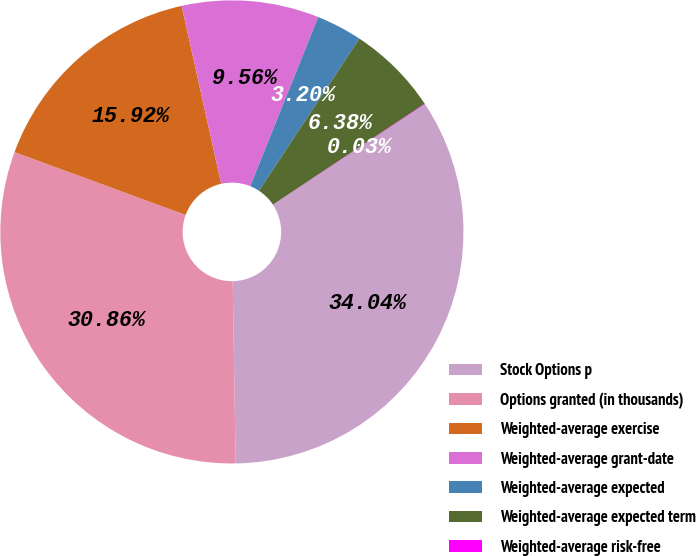Convert chart to OTSL. <chart><loc_0><loc_0><loc_500><loc_500><pie_chart><fcel>Stock Options p<fcel>Options granted (in thousands)<fcel>Weighted-average exercise<fcel>Weighted-average grant-date<fcel>Weighted-average expected<fcel>Weighted-average expected term<fcel>Weighted-average risk-free<nl><fcel>34.04%<fcel>30.86%<fcel>15.92%<fcel>9.56%<fcel>3.2%<fcel>6.38%<fcel>0.03%<nl></chart> 